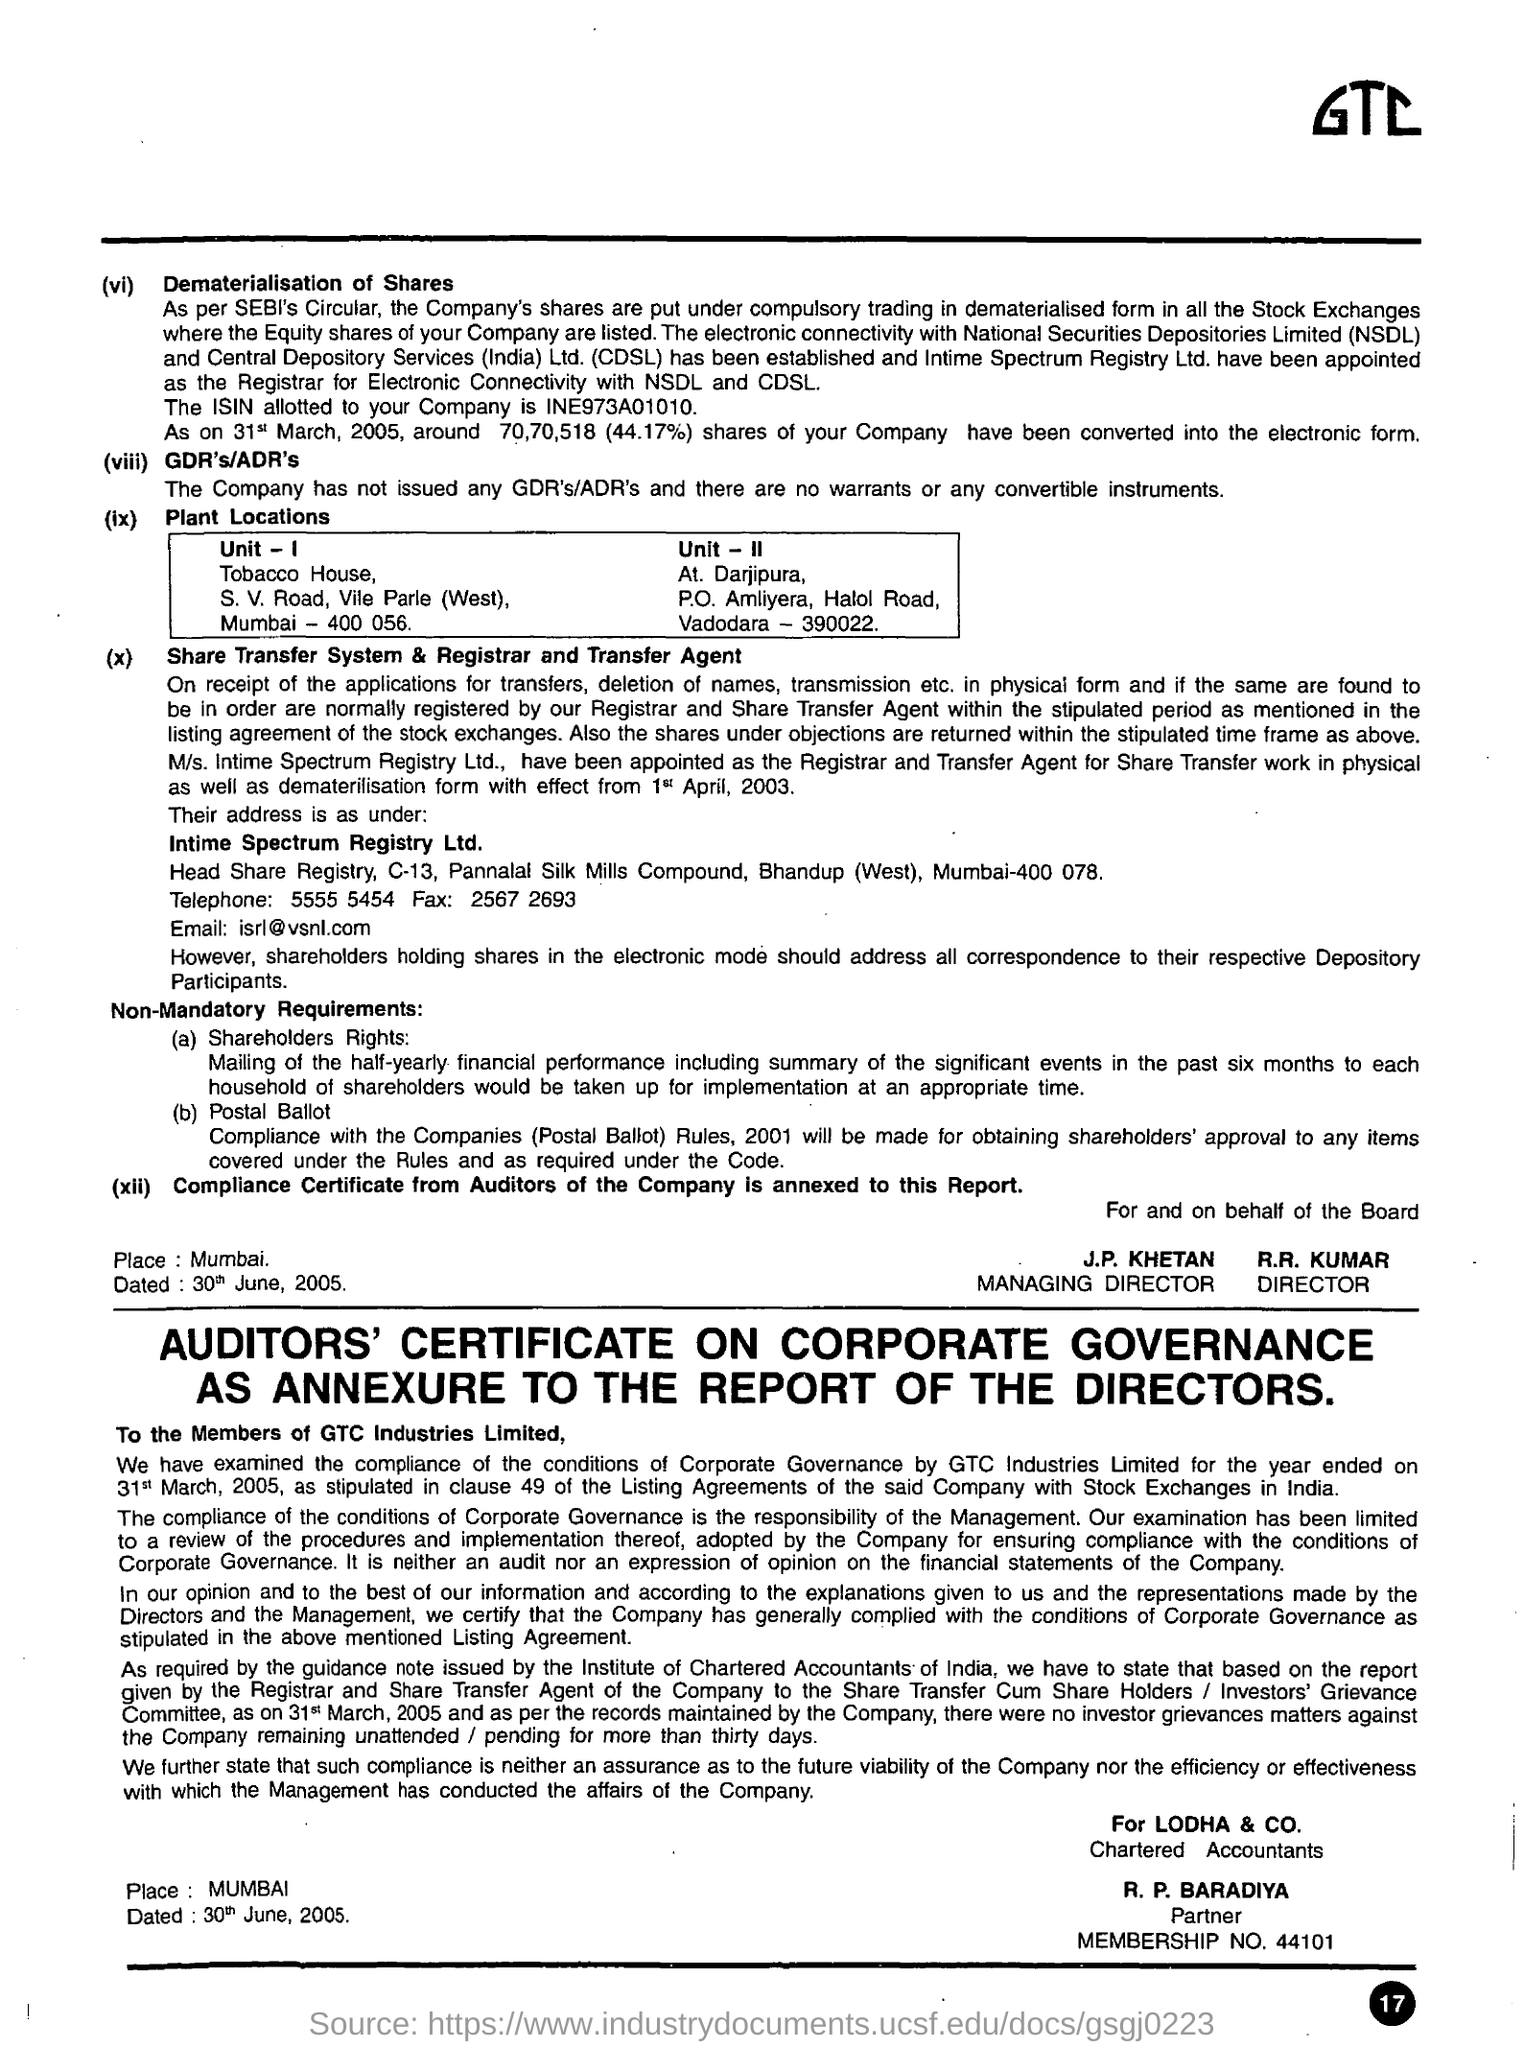What is the City for Plant Location Unit - I?
Make the answer very short. Mumbai. What is the City for Plant Location Unit - II?
Your response must be concise. Vadodara. Who is the managing director?
Give a very brief answer. J.P. Khetan. Who is the Director?
Your answer should be very brief. R.R. Kumar. 